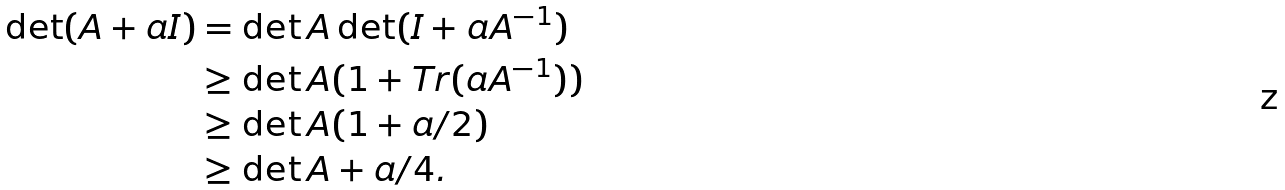Convert formula to latex. <formula><loc_0><loc_0><loc_500><loc_500>\det ( A + a I ) & = \det A \det ( I + a A ^ { - 1 } ) \\ & \geq \det A ( 1 + T r ( a A ^ { - 1 } ) ) \\ & \geq \det A ( 1 + a / 2 ) \\ & \geq \det A + a / 4 .</formula> 